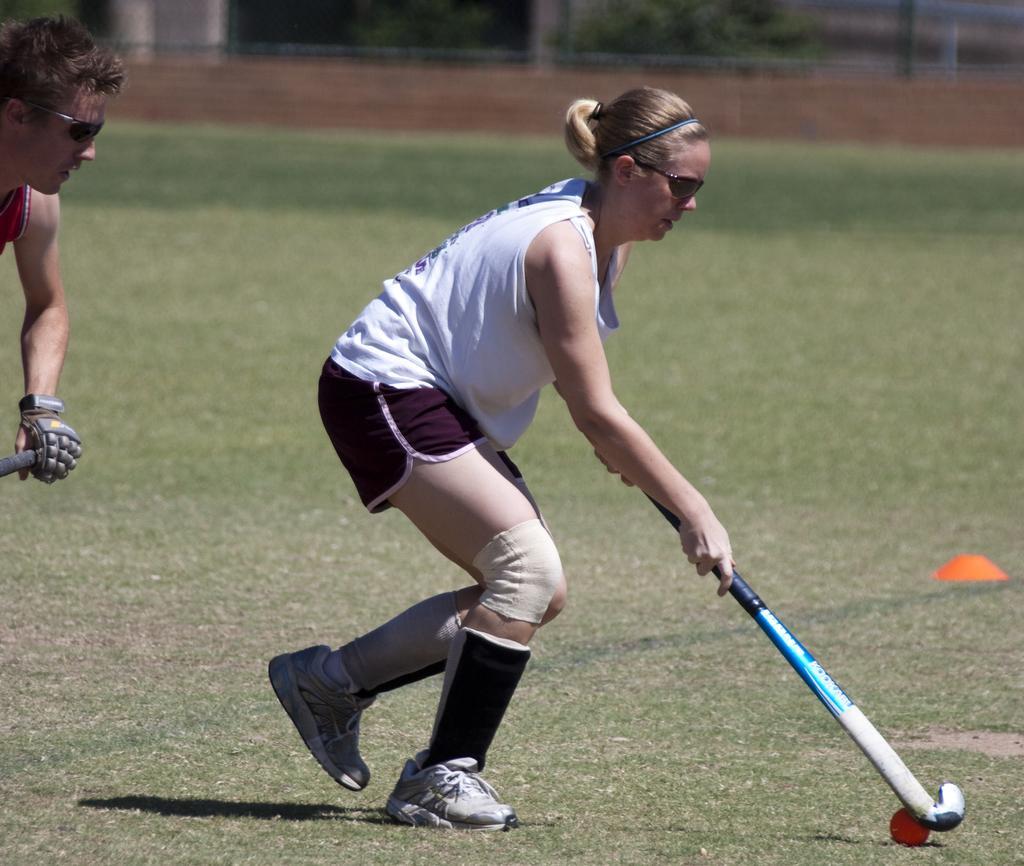How would you summarize this image in a sentence or two? In this image I can see two persons and I can see both of them are holding hockey sticks. I can also see both of them are wearing shades. Here I can see a red colour ball, a orange colour thing and grass ground. I can see he is wearing a glove, red colour dress and she is wearing white colour dress. 